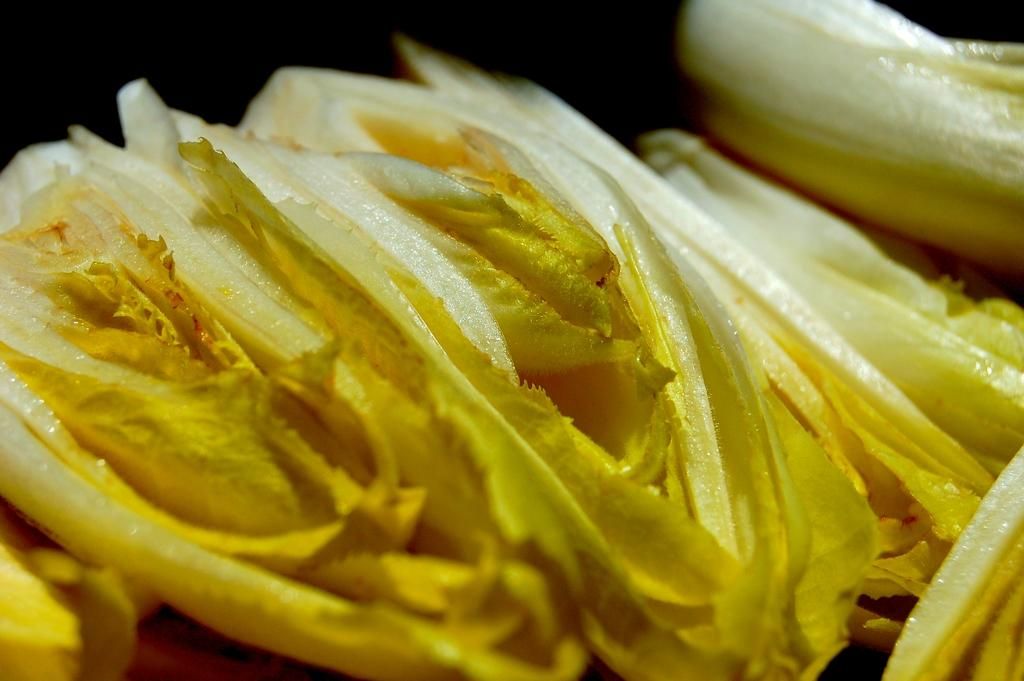What can be seen in the image that might resemble food items? There are objects in the image that resemble food items. What is the color of the background in the image? The background of the image is dark. How does the crowd react to the top reward in the image? There is no crowd or reward present in the image; it only features objects that resemble food items with a dark background. 